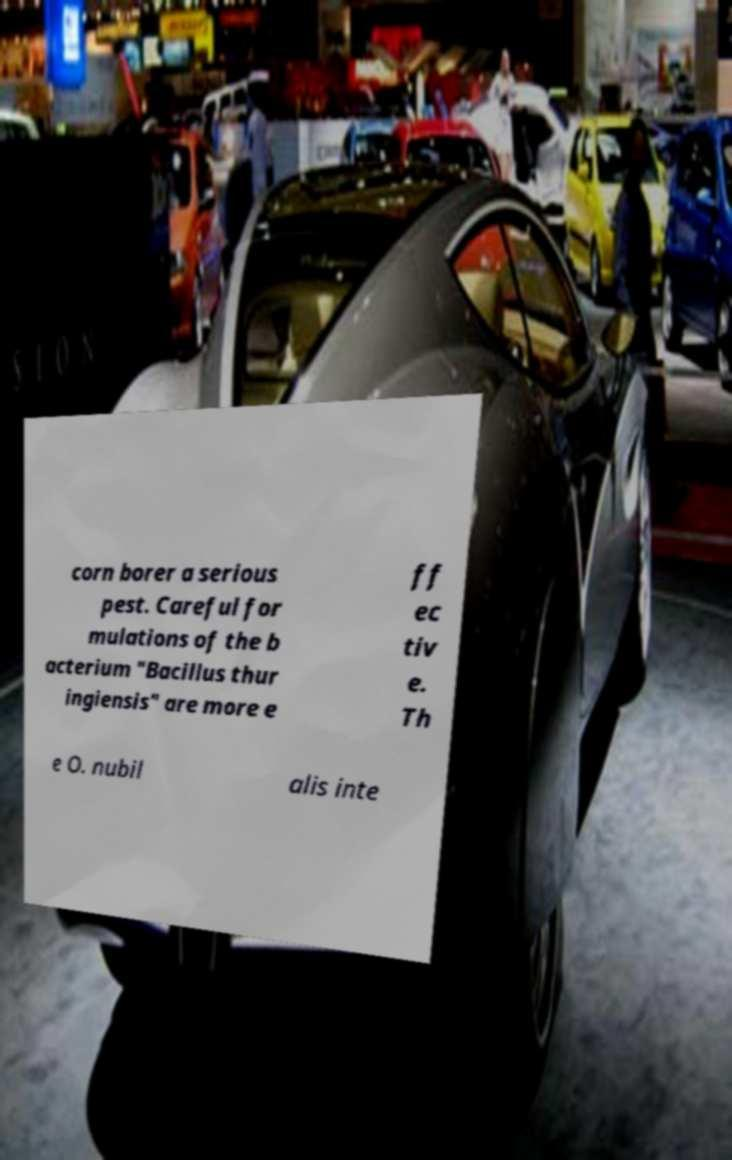Please read and relay the text visible in this image. What does it say? corn borer a serious pest. Careful for mulations of the b acterium "Bacillus thur ingiensis" are more e ff ec tiv e. Th e O. nubil alis inte 